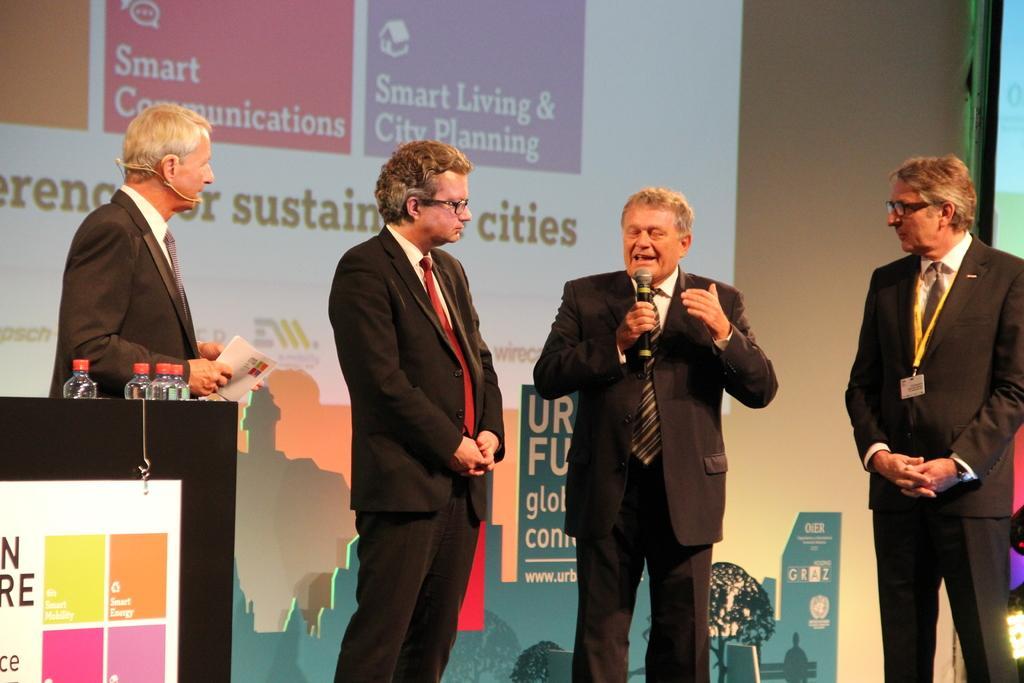Please provide a concise description of this image. In this image we can see four men standing, one black podium, four water bottles on the podium, one board with text hanged, one man wearing an ID card on the left side of the image, one banner with text and images in the background. There is one light on the bottom right side of the image, one screen and one object on the right side of the image. One man wearing a microphone and holding a book. One man holding a microphone and talking. 